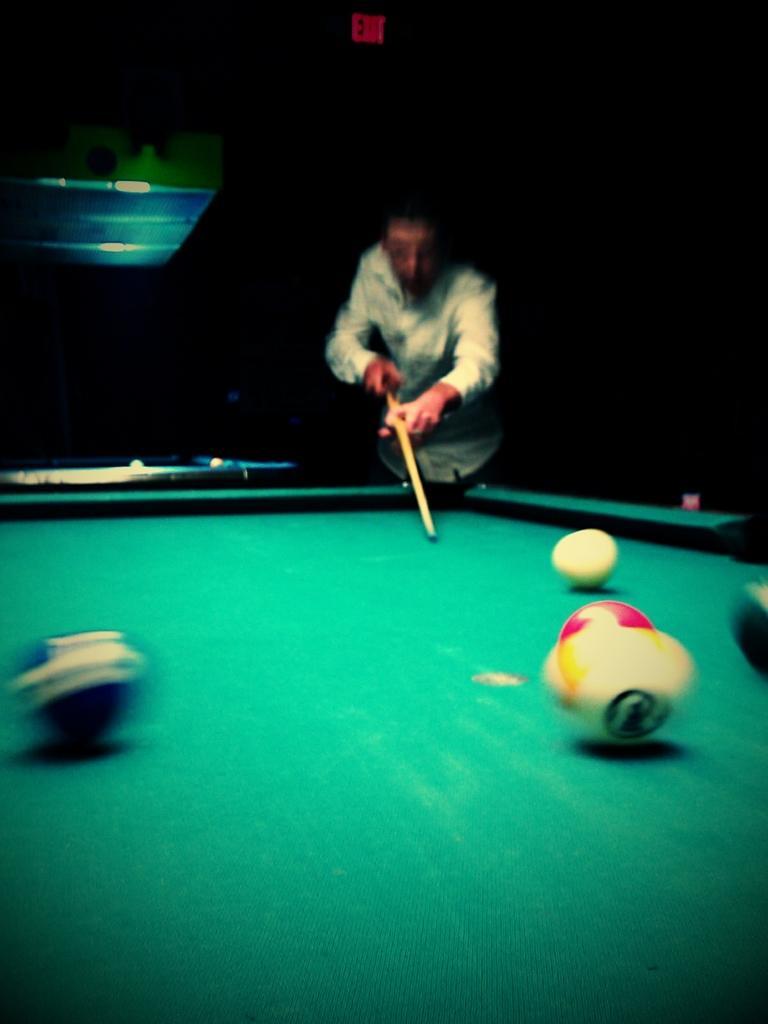How would you summarize this image in a sentence or two? In this image we can see a man playing snooker. 